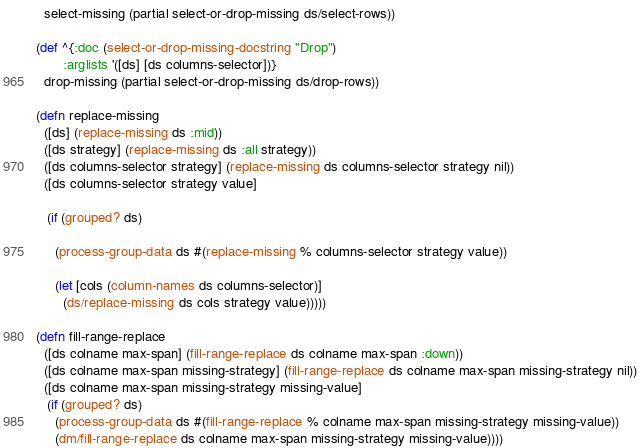Convert code to text. <code><loc_0><loc_0><loc_500><loc_500><_Clojure_>  select-missing (partial select-or-drop-missing ds/select-rows))

(def ^{:doc (select-or-drop-missing-docstring "Drop")
       :arglists '([ds] [ds columns-selector])}
  drop-missing (partial select-or-drop-missing ds/drop-rows))

(defn replace-missing
  ([ds] (replace-missing ds :mid))
  ([ds strategy] (replace-missing ds :all strategy))
  ([ds columns-selector strategy] (replace-missing ds columns-selector strategy nil))
  ([ds columns-selector strategy value]

   (if (grouped? ds)

     (process-group-data ds #(replace-missing % columns-selector strategy value))
     
     (let [cols (column-names ds columns-selector)]
       (ds/replace-missing ds cols strategy value)))))

(defn fill-range-replace
  ([ds colname max-span] (fill-range-replace ds colname max-span :down))
  ([ds colname max-span missing-strategy] (fill-range-replace ds colname max-span missing-strategy nil))
  ([ds colname max-span missing-strategy missing-value]
   (if (grouped? ds)
     (process-group-data ds #(fill-range-replace % colname max-span missing-strategy missing-value))
     (dm/fill-range-replace ds colname max-span missing-strategy missing-value))))

</code> 